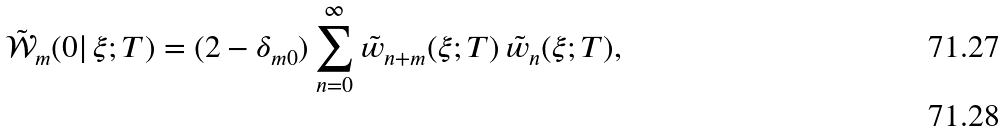<formula> <loc_0><loc_0><loc_500><loc_500>\tilde { \mathcal { W } } _ { m } ( 0 | \, \xi ; T ) = ( 2 - \delta _ { m 0 } ) \sum _ { n = 0 } ^ { \infty } { \tilde { w } } _ { n + m } ( \xi ; T ) \, { \tilde { w } } _ { n } ( \xi ; T ) , \\</formula> 